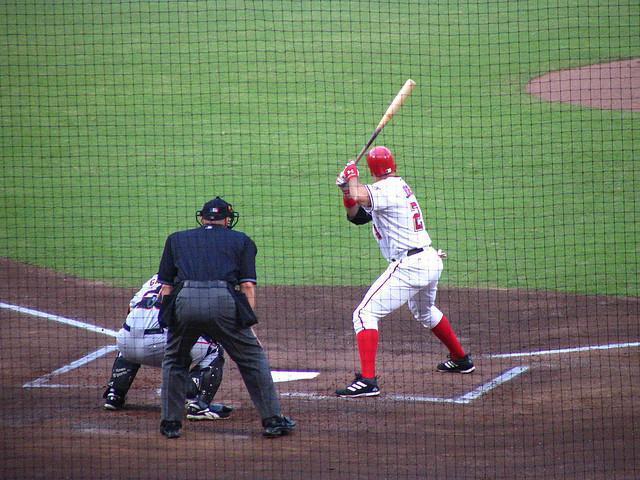How many people?
Give a very brief answer. 3. How many people are in the photo?
Give a very brief answer. 3. How many white toy boats with blue rim floating in the pond ?
Give a very brief answer. 0. 